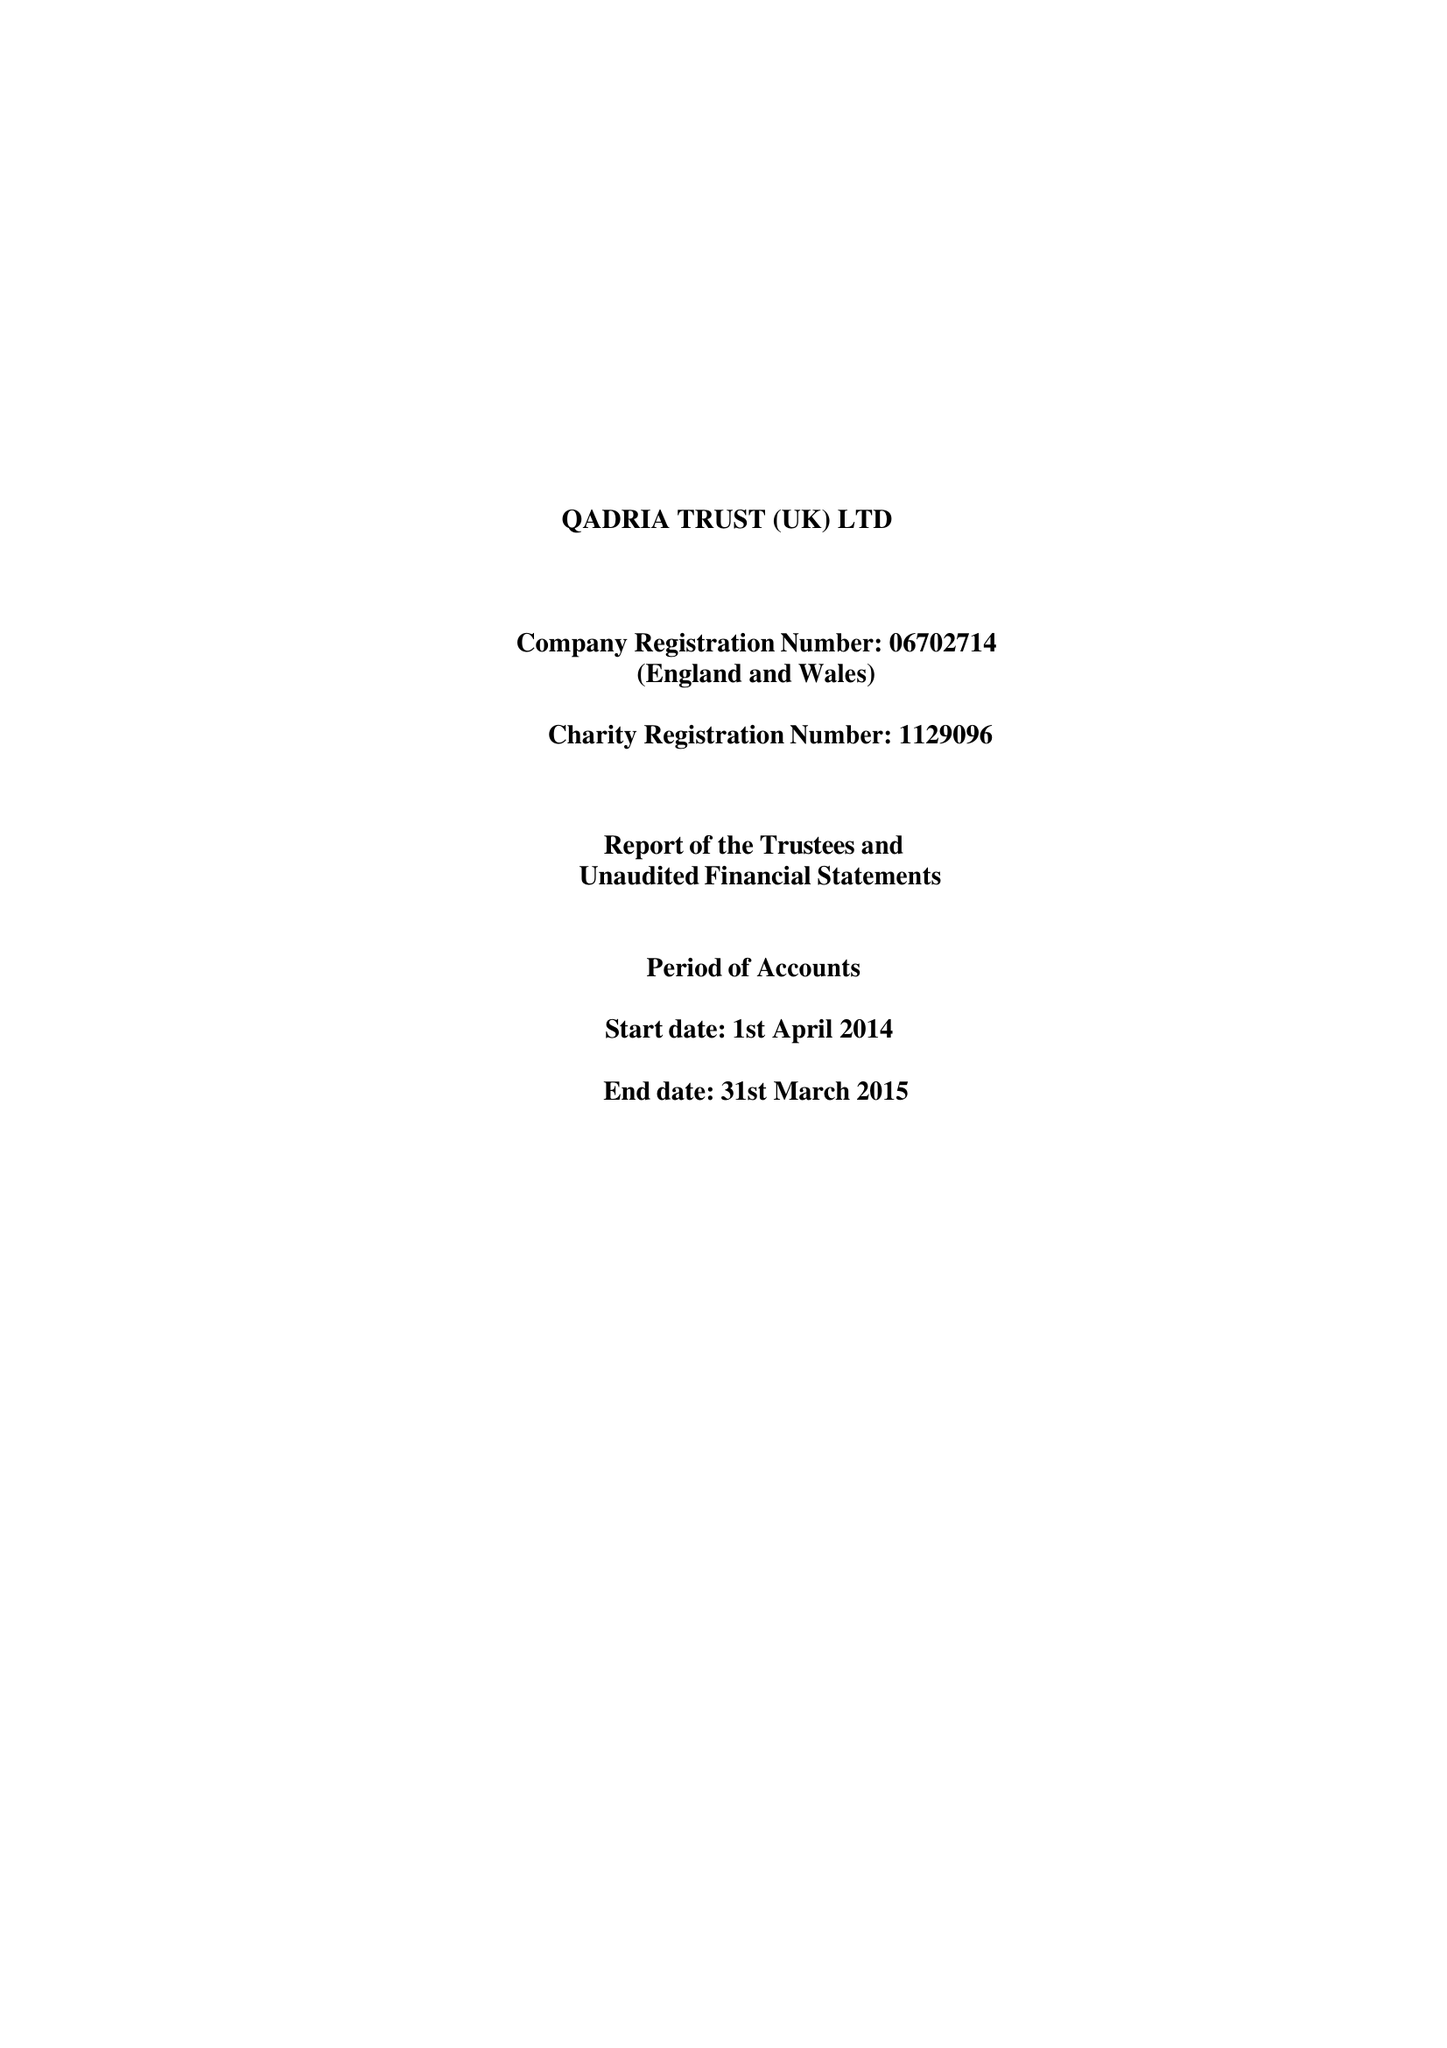What is the value for the income_annually_in_british_pounds?
Answer the question using a single word or phrase. 164508.00 